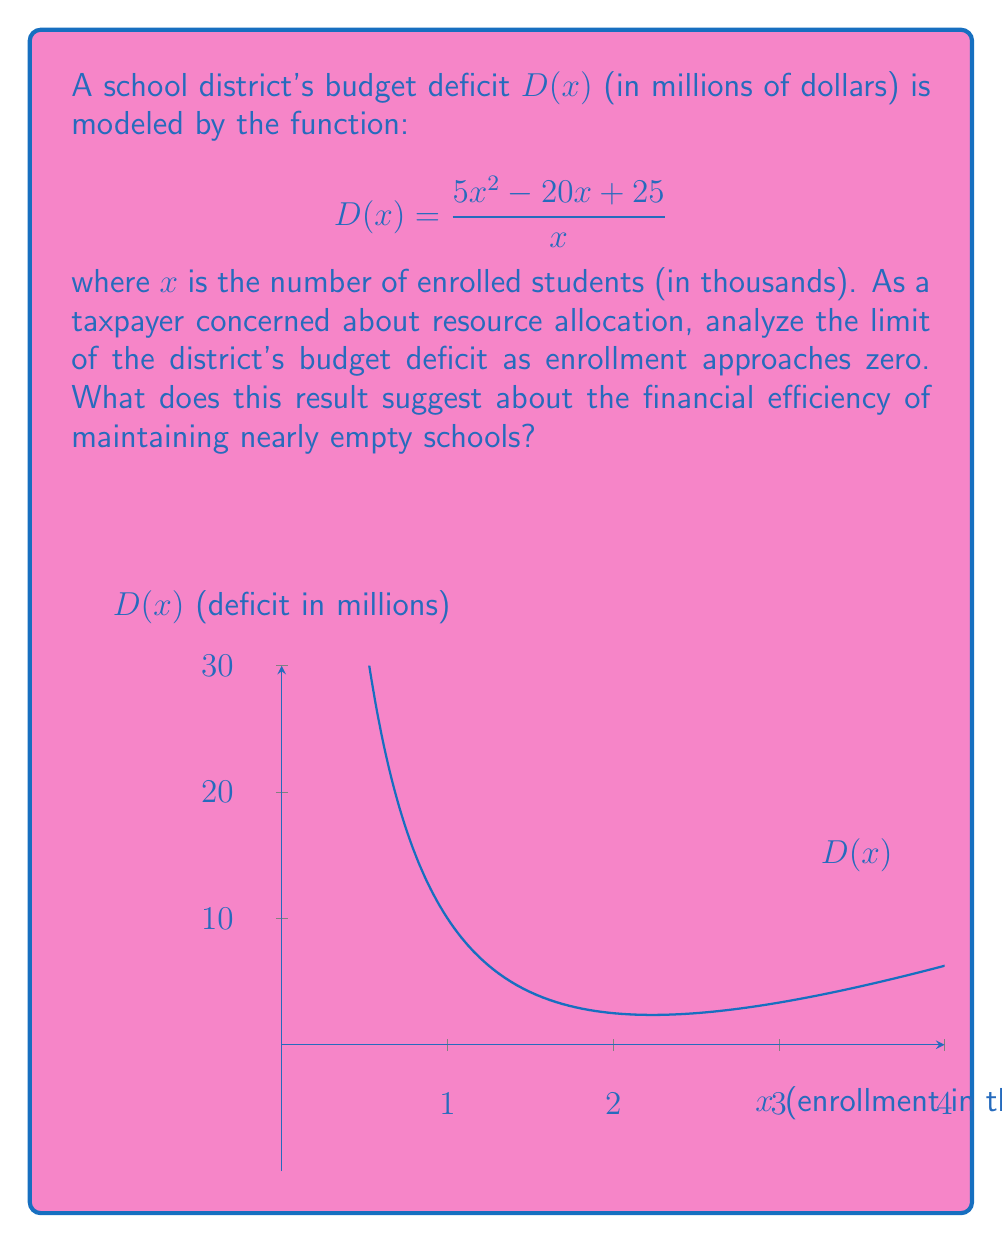Provide a solution to this math problem. To analyze the limit of the budget deficit as enrollment approaches zero, we need to evaluate:

$$\lim_{x \to 0^+} \frac{5x^2 - 20x + 25}{x}$$

1) First, let's try direct substitution:
   $$\lim_{x \to 0^+} \frac{5(0)^2 - 20(0) + 25}{0} = \frac{25}{0}$$
   This results in an indeterminate form of $\frac{25}{0}$.

2) Since we have an indeterminate form, we can use algebraic manipulation:
   $$\lim_{x \to 0^+} \frac{5x^2 - 20x + 25}{x} = \lim_{x \to 0^+} \left(5x - 20 + \frac{25}{x}\right)$$

3) Now we can evaluate the limit of each term:
   $$\lim_{x \to 0^+} 5x = 0$$
   $$\lim_{x \to 0^+} (-20) = -20$$
   $$\lim_{x \to 0^+} \frac{25}{x} = +\infty$$

4) Combining these results:
   $$\lim_{x \to 0^+} \left(5x - 20 + \frac{25}{x}\right) = 0 - 20 + (+\infty) = +\infty$$

This result suggests that as enrollment approaches zero, the budget deficit grows without bound. From a taxpayer's perspective, this indicates that maintaining schools with extremely low enrollment is financially inefficient, as fixed costs remain high while the number of students served approaches zero.
Answer: $+\infty$ 